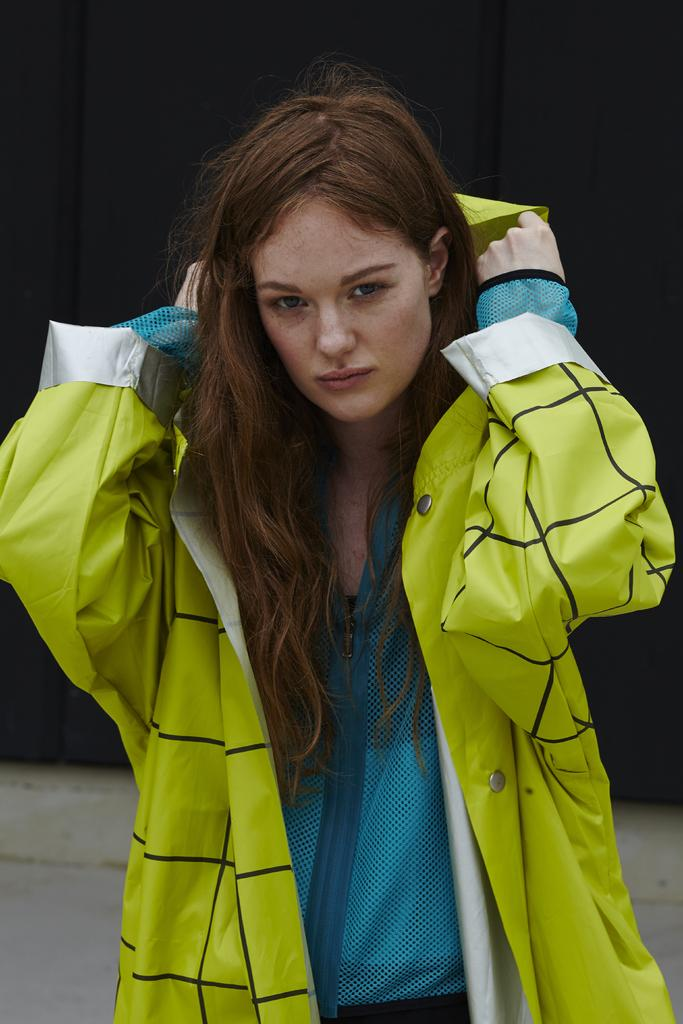Who is the main subject in the image? There is a woman in the image. What is the woman doing in the image? The woman is standing. What can be observed about the background of the image? The background of the image is dark. How many rails can be seen in the image? There are no rails present in the image. What unit of measurement is being used to determine the woman's height in the image? The image does not provide any information about the woman's height or the unit of measurement being used. 